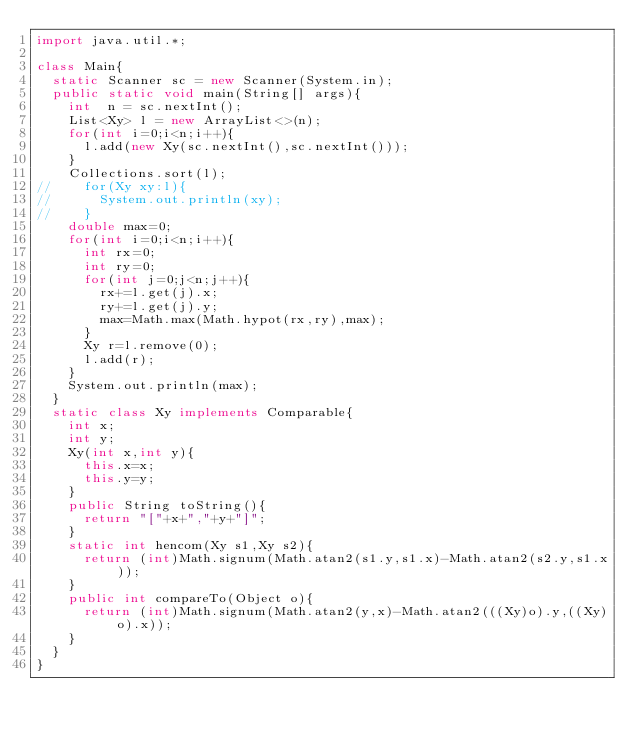Convert code to text. <code><loc_0><loc_0><loc_500><loc_500><_Java_>import java.util.*;

class Main{
  static Scanner sc = new Scanner(System.in);
  public static void main(String[] args){
    int  n = sc.nextInt();
    List<Xy> l = new ArrayList<>(n);
    for(int i=0;i<n;i++){
      l.add(new Xy(sc.nextInt(),sc.nextInt()));
    }
    Collections.sort(l);
//    for(Xy xy:l){
//      System.out.println(xy);
//    }
    double max=0;
    for(int i=0;i<n;i++){
      int rx=0;
      int ry=0;
      for(int j=0;j<n;j++){
        rx+=l.get(j).x;
        ry+=l.get(j).y;
        max=Math.max(Math.hypot(rx,ry),max);
      }
      Xy r=l.remove(0);
      l.add(r);
    }
    System.out.println(max);
  }
  static class Xy implements Comparable{
    int x;
    int y;
    Xy(int x,int y){
      this.x=x;
      this.y=y;
    }
    public String toString(){
      return "["+x+","+y+"]";
    }
    static int hencom(Xy s1,Xy s2){
      return (int)Math.signum(Math.atan2(s1.y,s1.x)-Math.atan2(s2.y,s1.x));
    }
    public int compareTo(Object o){
      return (int)Math.signum(Math.atan2(y,x)-Math.atan2(((Xy)o).y,((Xy)o).x));
    }
  }
}
</code> 